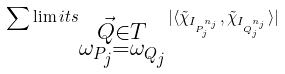<formula> <loc_0><loc_0><loc_500><loc_500>\sum \lim i t s _ { \substack { \vec { Q } \in T \\ \omega _ { P _ { j } } = \omega _ { Q _ { j } } } } | \langle \tilde { \chi } _ { I _ { P _ { j } ^ { n _ { j } } } } , \tilde { \chi } _ { I _ { Q _ { j } ^ { n _ { j } } } } \rangle |</formula> 